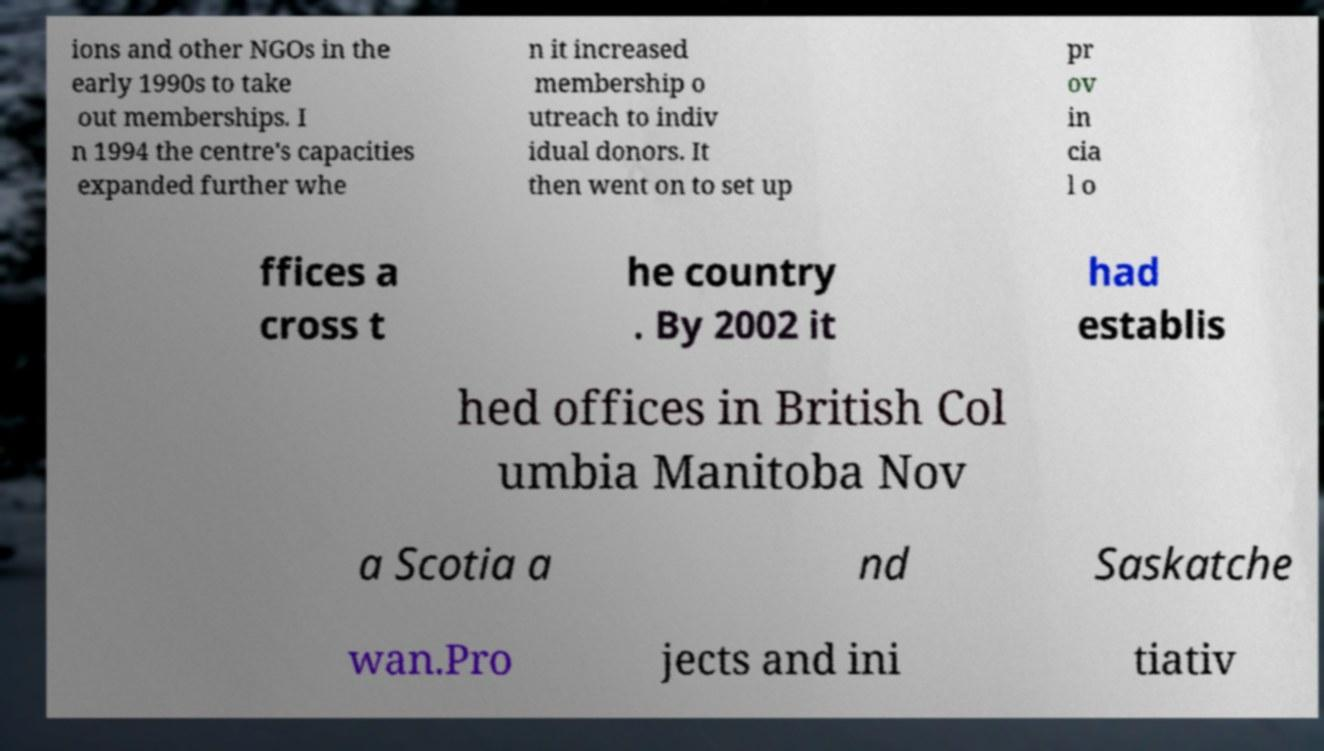Please read and relay the text visible in this image. What does it say? ions and other NGOs in the early 1990s to take out memberships. I n 1994 the centre's capacities expanded further whe n it increased membership o utreach to indiv idual donors. It then went on to set up pr ov in cia l o ffices a cross t he country . By 2002 it had establis hed offices in British Col umbia Manitoba Nov a Scotia a nd Saskatche wan.Pro jects and ini tiativ 